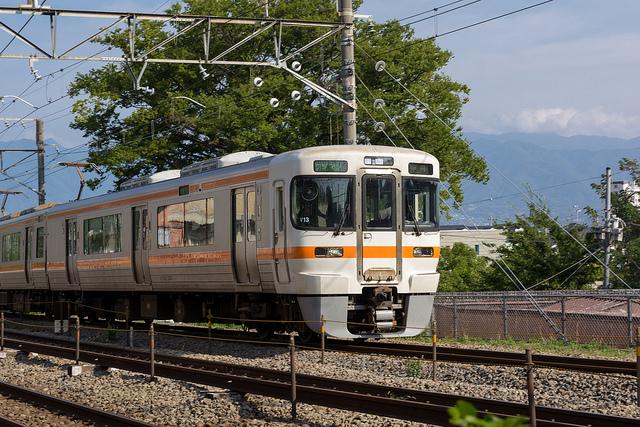What does this train carry?
Give a very brief answer. People. What color is the stripe on the train?
Short answer required. Orange. What time of day is it?
Be succinct. Morning. Could this train be electrically powered?
Be succinct. Yes. 